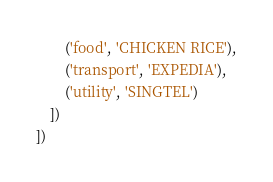<code> <loc_0><loc_0><loc_500><loc_500><_Python_>        ('food', 'CHICKEN RICE'),
        ('transport', 'EXPEDIA'),
        ('utility', 'SINGTEL')
    ])
])
</code> 